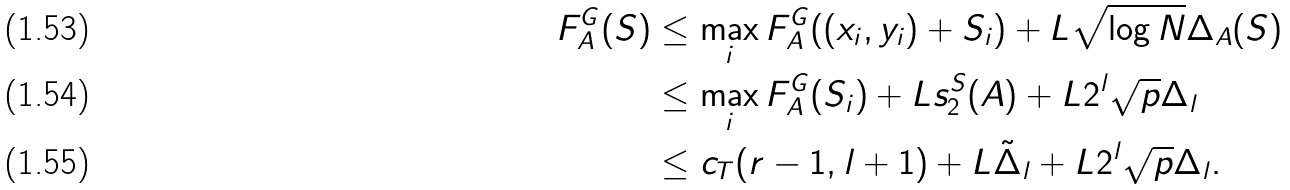<formula> <loc_0><loc_0><loc_500><loc_500>F _ { A } ^ { G } ( S ) & \leq \max _ { i } F _ { A } ^ { G } ( ( x _ { i } , y _ { i } ) + S _ { i } ) + L \sqrt { \log N } \Delta _ { A } ( S ) \\ & \leq \max _ { i } F _ { A } ^ { G } ( S _ { i } ) + L s _ { 2 } ^ { S } ( A ) + L 2 ^ { l } \sqrt { p } \Delta _ { l } \\ & \leq c _ { T } ( r - 1 , l + 1 ) + L \tilde { \Delta } _ { l } + L 2 ^ { l } \sqrt { p } \Delta _ { l } .</formula> 